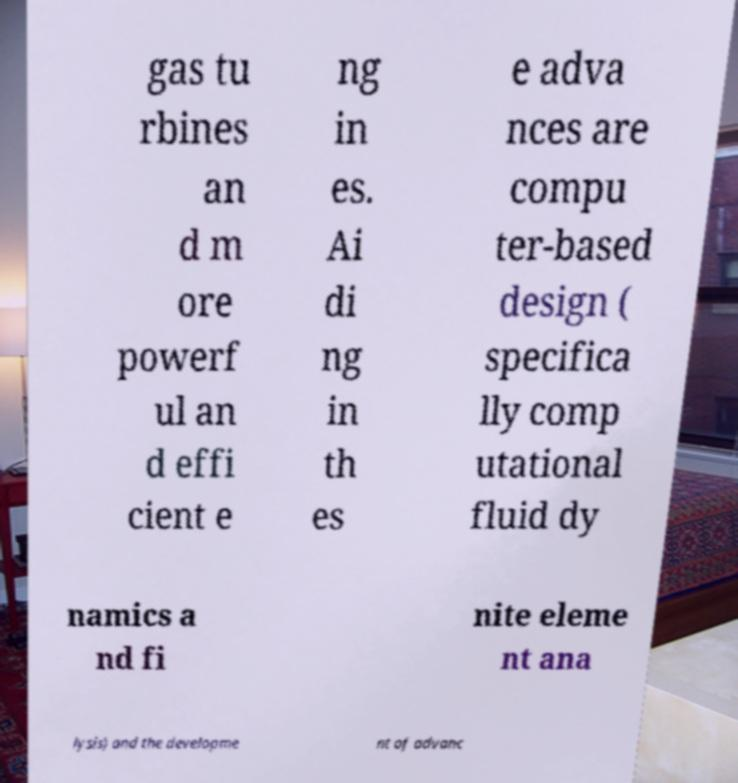What messages or text are displayed in this image? I need them in a readable, typed format. gas tu rbines an d m ore powerf ul an d effi cient e ng in es. Ai di ng in th es e adva nces are compu ter-based design ( specifica lly comp utational fluid dy namics a nd fi nite eleme nt ana lysis) and the developme nt of advanc 